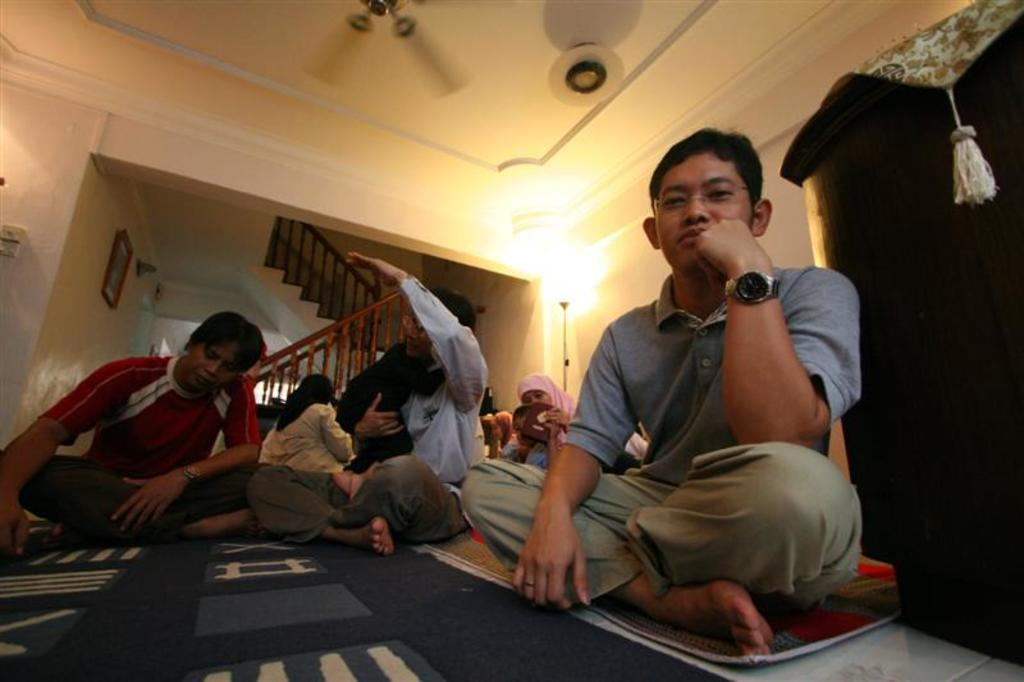What are the people in the image doing? The people in the image are sitting on the floor. What architectural feature can be seen in the image? There are stairs and railings in the image. What is hanging on the wall in the image? There is a photo frame on the wall in the image. What can be seen at the top of the image? There is a fan visible at the top of the image. What type of lighting is present in the image? There are lights present in the image. Are there any fairies visible in the image? There are no fairies present in the image. How does the image start to move on its own? The image does not move on its own; it is a static representation. 